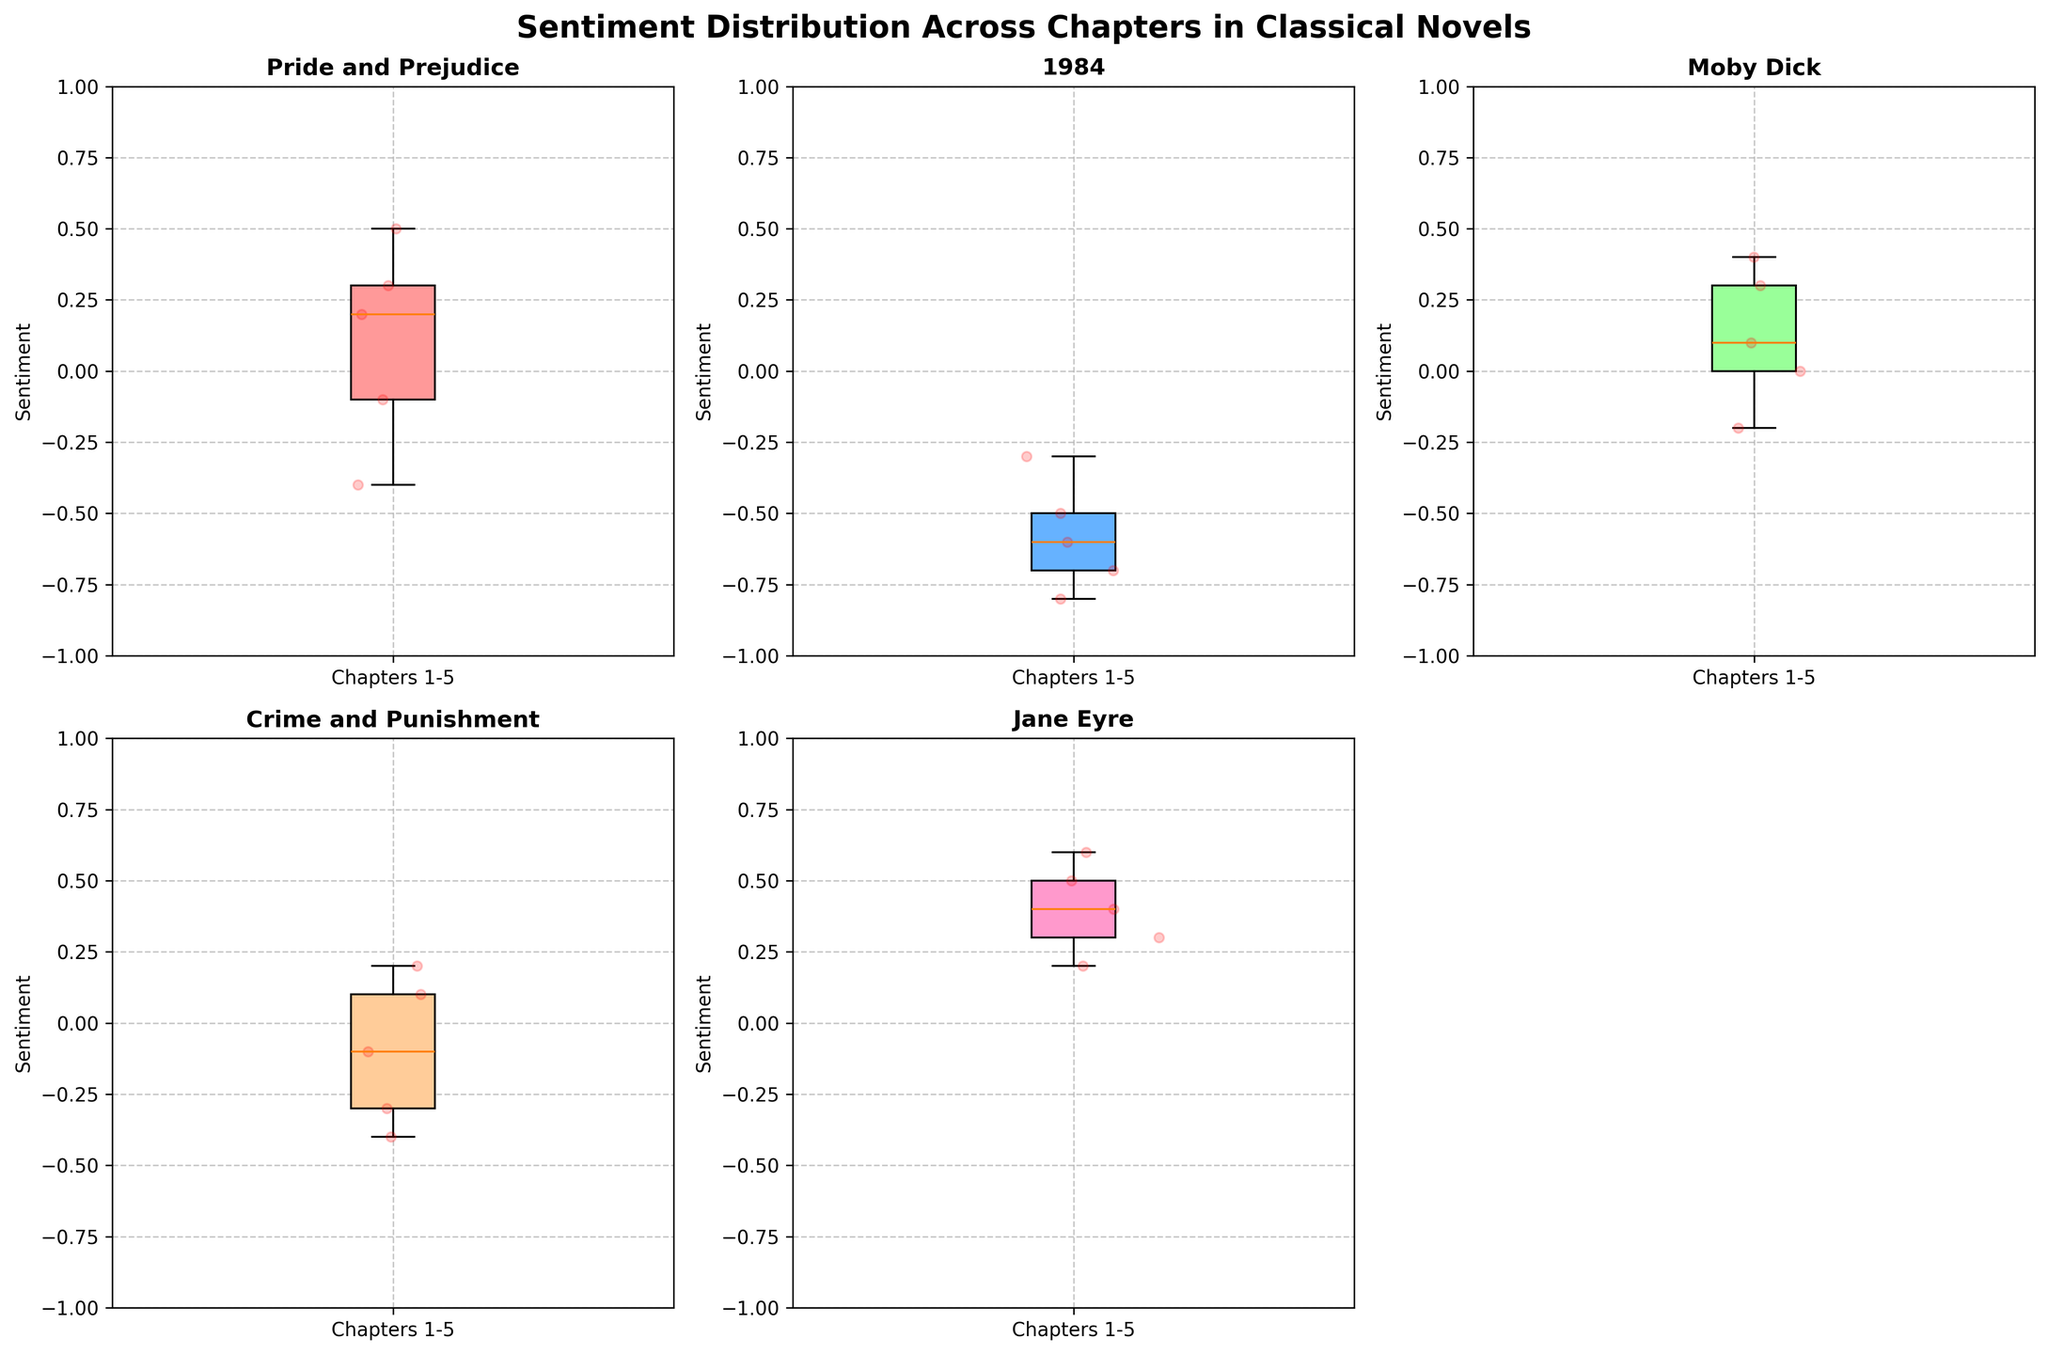What is the overall title of the figure? The overall title of the figure can be found at the top of the plot where it provides a summary of what the figure is about.
Answer: Sentiment Distribution Across Chapters in Classical Novels How many novels are compared in the figure? By counting the number of unique subplot titles, we can determine the number of novels included in the comparison.
Answer: 5 Which novel has a positive average sentiment across the chapters? By examining the position of the boxes across the y-axis in each subplot, we can determine if the average sentiment is positive. Look for boxes that are generally in the positive region.
Answer: Jane Eyre What's the range of sentiments in '1984'? The range is determined by the distance between the lowest and highest sentiment points in the novel’s box plot. Subtract the minimum value from the maximum value.
Answer: The range is from about -0.8 to -0.3 Which novels have chapters with negative sentiments? Identify the box plots that have boxes or points in the negative sentiment region on the y-axis.
Answer: Pride and Prejudice, 1984, Moby Dick, Crime and Punishment Between 'Pride and Prejudice' and 'Moby Dick,' which novel shows a greater variability in sentiment? Variability can be observed by comparing the IQR (Interquartile Range) of the novels' box plots. A larger box indicates greater variability.
Answer: Moby Dick What is the median sentiment of 'Crime and Punishment'? The median sentiment is represented by the line inside the box of the box plot. Look at its position relative to the y-axis.
Answer: Approximately -0.1 Which novel has the most consistently positive sentiment across its chapters? Consistency can be inferred from the length of the boxes (IQR) and the position of the median. Look for shorter boxes in the positive region.
Answer: Jane Eyre Compare the sentiments of the first chapters for 'Pride and Prejudice' and '1984.' Which one is more positive? Find the specific data points for the first chapter in both subplots and compare their positions on the y-axis.
Answer: Pride and Prejudice 